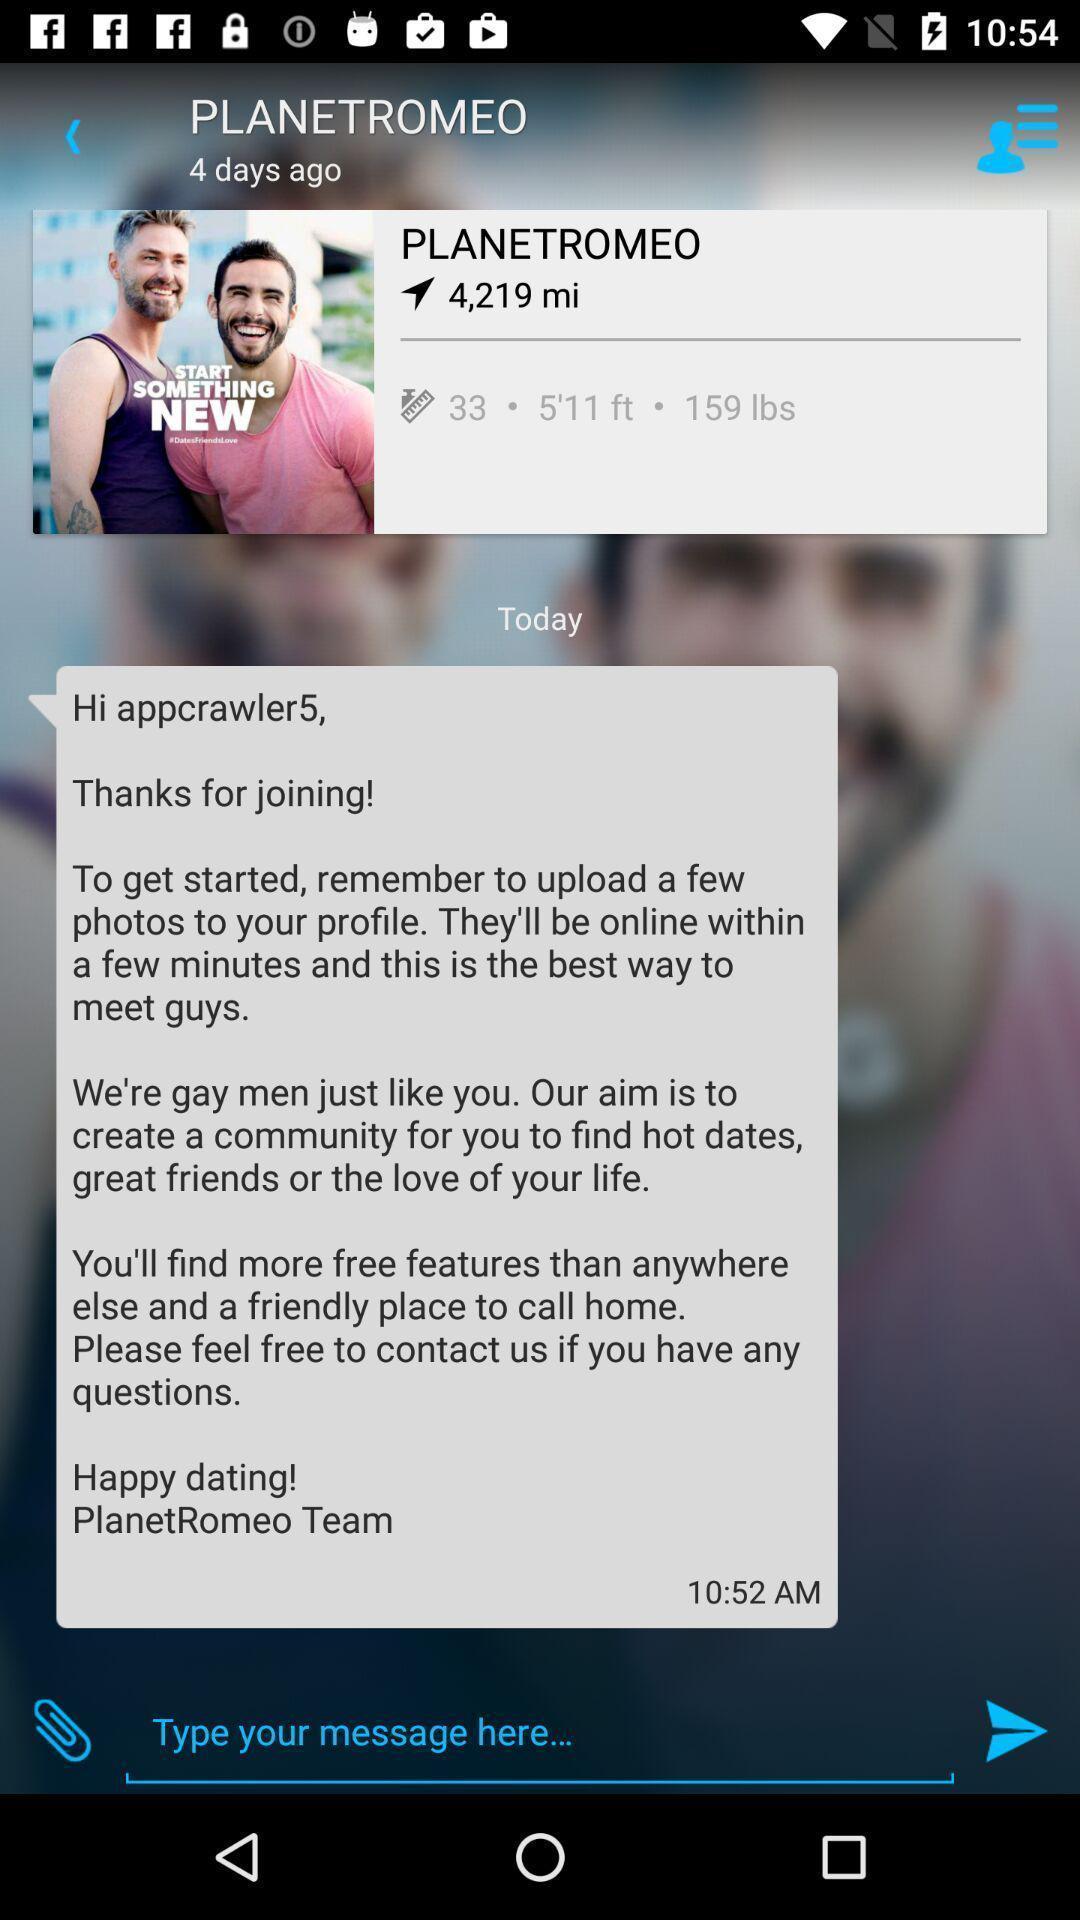Explain what's happening in this screen capture. Page displaying text messages of an chat app. 